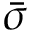<formula> <loc_0><loc_0><loc_500><loc_500>\bar { \sigma }</formula> 